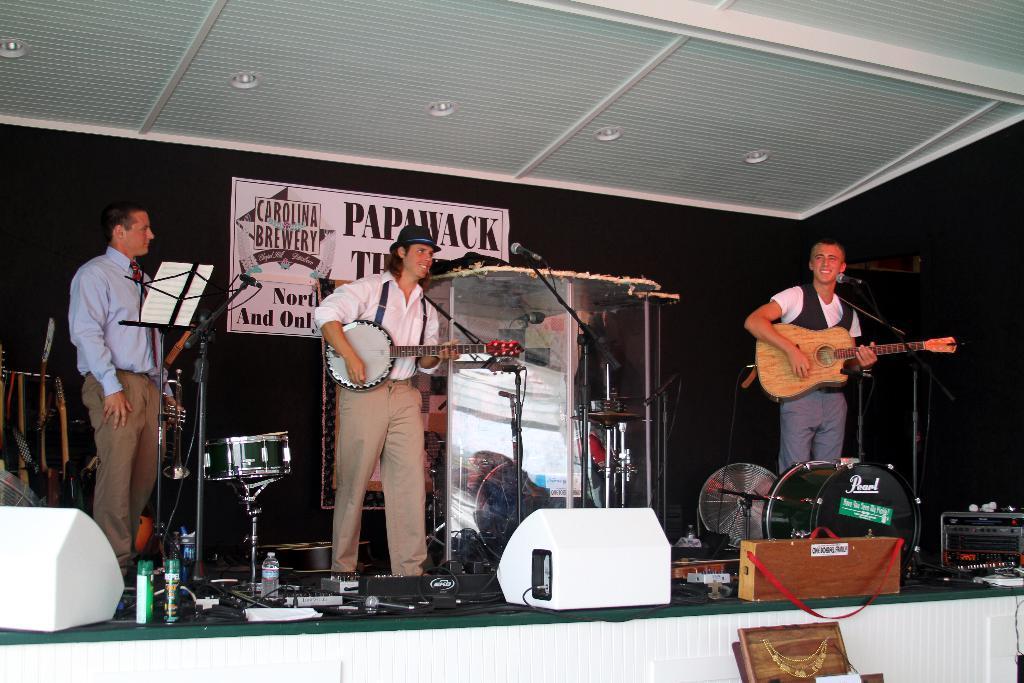In one or two sentences, can you explain what this image depicts? In this picture there are three people those who are on the stage the person who is left side of the stage his, having a paper in front of him on holder, the person who is at the center of the stage holding a guitar in his hand and the person who is at the right side of the stage is holding a guitar and there is a mic in front of him, it seems to be a music event and there are musical instruments on the stage, there is a white color ceiling above the stage. 